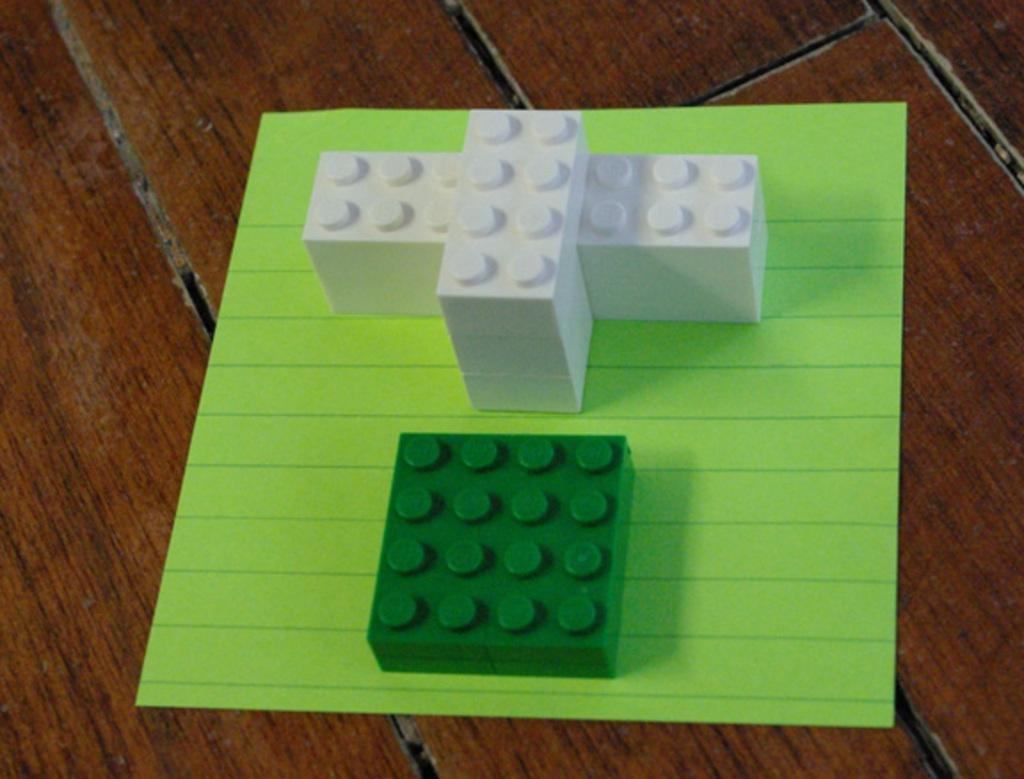What is the color of the object on the floor in the image? The object is green and white. Where is the object located in the image? The object is placed on the floor. What color is the background of the image? The background of the image is green. How many patches can be seen on the hen in the image? There is no hen present in the image, so it is not possible to determine the number of patches. 